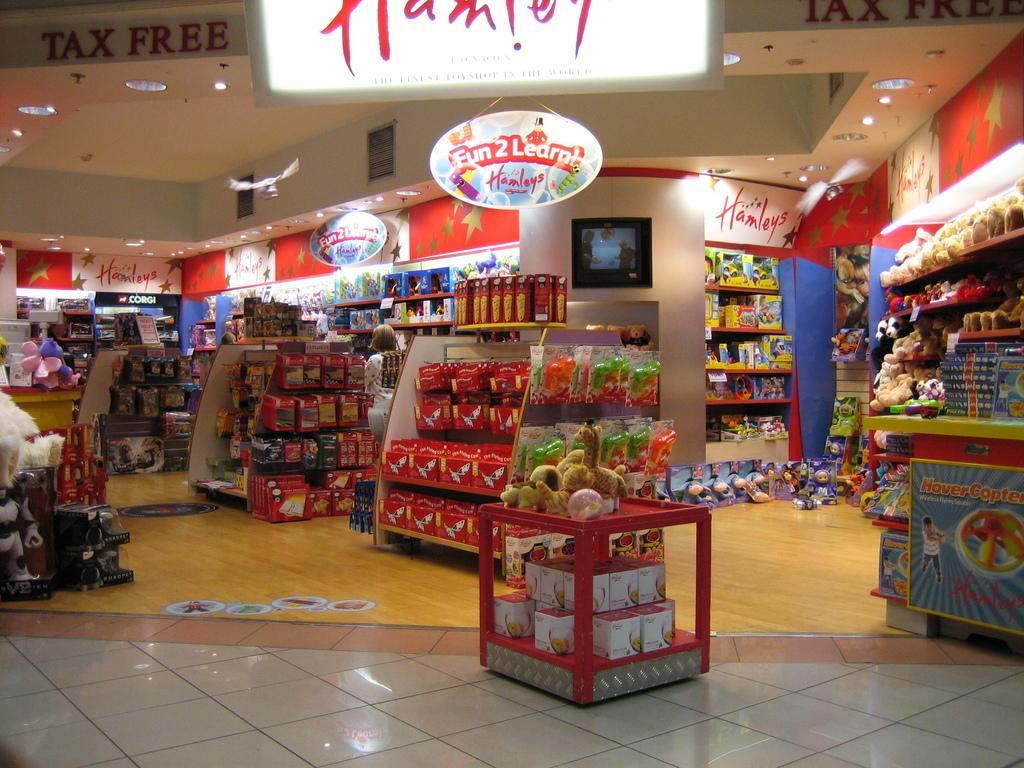<image>
Relay a brief, clear account of the picture shown. Displays in a store where everything is TAX FREE 